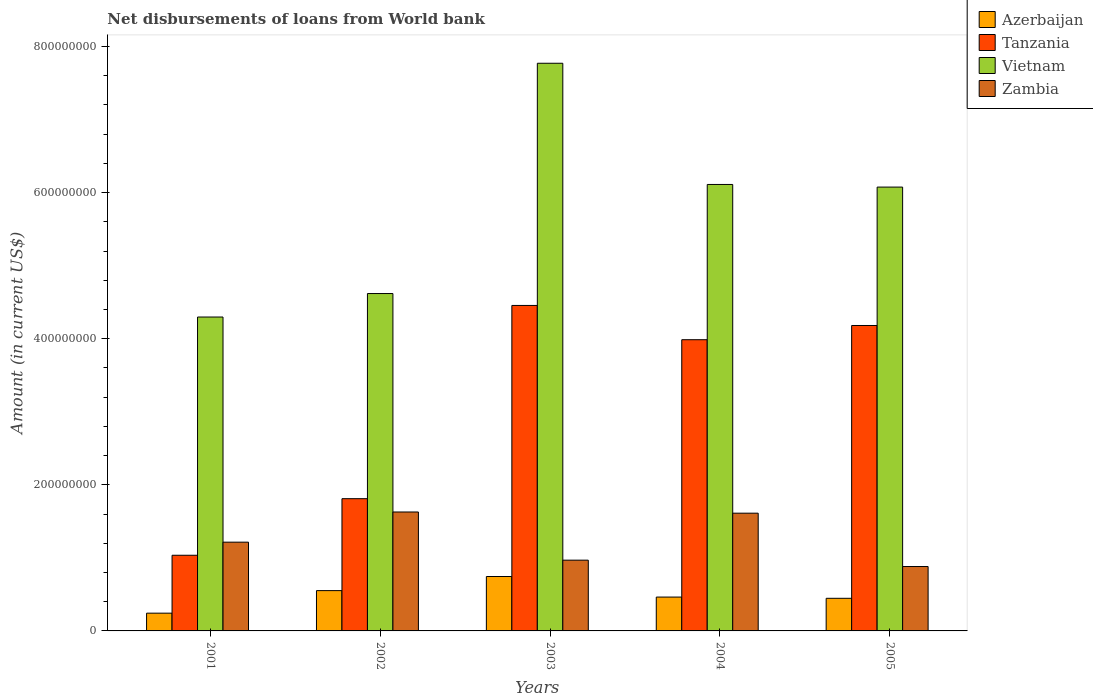Are the number of bars per tick equal to the number of legend labels?
Make the answer very short. Yes. Are the number of bars on each tick of the X-axis equal?
Your answer should be compact. Yes. What is the amount of loan disbursed from World Bank in Tanzania in 2003?
Your answer should be compact. 4.46e+08. Across all years, what is the maximum amount of loan disbursed from World Bank in Vietnam?
Give a very brief answer. 7.77e+08. Across all years, what is the minimum amount of loan disbursed from World Bank in Zambia?
Your answer should be very brief. 8.81e+07. What is the total amount of loan disbursed from World Bank in Azerbaijan in the graph?
Offer a very short reply. 2.45e+08. What is the difference between the amount of loan disbursed from World Bank in Tanzania in 2001 and that in 2003?
Offer a terse response. -3.42e+08. What is the difference between the amount of loan disbursed from World Bank in Tanzania in 2005 and the amount of loan disbursed from World Bank in Vietnam in 2001?
Provide a short and direct response. -1.16e+07. What is the average amount of loan disbursed from World Bank in Vietnam per year?
Your answer should be compact. 5.77e+08. In the year 2005, what is the difference between the amount of loan disbursed from World Bank in Vietnam and amount of loan disbursed from World Bank in Azerbaijan?
Provide a short and direct response. 5.63e+08. In how many years, is the amount of loan disbursed from World Bank in Zambia greater than 480000000 US$?
Give a very brief answer. 0. What is the ratio of the amount of loan disbursed from World Bank in Tanzania in 2002 to that in 2004?
Provide a succinct answer. 0.45. Is the amount of loan disbursed from World Bank in Azerbaijan in 2002 less than that in 2005?
Ensure brevity in your answer.  No. What is the difference between the highest and the second highest amount of loan disbursed from World Bank in Tanzania?
Provide a succinct answer. 2.74e+07. What is the difference between the highest and the lowest amount of loan disbursed from World Bank in Tanzania?
Provide a short and direct response. 3.42e+08. Is the sum of the amount of loan disbursed from World Bank in Azerbaijan in 2003 and 2005 greater than the maximum amount of loan disbursed from World Bank in Vietnam across all years?
Your response must be concise. No. Is it the case that in every year, the sum of the amount of loan disbursed from World Bank in Zambia and amount of loan disbursed from World Bank in Vietnam is greater than the sum of amount of loan disbursed from World Bank in Tanzania and amount of loan disbursed from World Bank in Azerbaijan?
Offer a terse response. Yes. What does the 2nd bar from the left in 2005 represents?
Keep it short and to the point. Tanzania. What does the 2nd bar from the right in 2005 represents?
Give a very brief answer. Vietnam. How many bars are there?
Offer a terse response. 20. How many years are there in the graph?
Ensure brevity in your answer.  5. Does the graph contain any zero values?
Provide a succinct answer. No. Where does the legend appear in the graph?
Provide a short and direct response. Top right. What is the title of the graph?
Provide a succinct answer. Net disbursements of loans from World bank. What is the label or title of the Y-axis?
Your answer should be compact. Amount (in current US$). What is the Amount (in current US$) of Azerbaijan in 2001?
Provide a succinct answer. 2.43e+07. What is the Amount (in current US$) in Tanzania in 2001?
Your answer should be compact. 1.04e+08. What is the Amount (in current US$) in Vietnam in 2001?
Offer a very short reply. 4.30e+08. What is the Amount (in current US$) of Zambia in 2001?
Offer a terse response. 1.21e+08. What is the Amount (in current US$) of Azerbaijan in 2002?
Ensure brevity in your answer.  5.52e+07. What is the Amount (in current US$) in Tanzania in 2002?
Your response must be concise. 1.81e+08. What is the Amount (in current US$) of Vietnam in 2002?
Ensure brevity in your answer.  4.62e+08. What is the Amount (in current US$) in Zambia in 2002?
Give a very brief answer. 1.63e+08. What is the Amount (in current US$) of Azerbaijan in 2003?
Make the answer very short. 7.45e+07. What is the Amount (in current US$) of Tanzania in 2003?
Ensure brevity in your answer.  4.46e+08. What is the Amount (in current US$) in Vietnam in 2003?
Your answer should be very brief. 7.77e+08. What is the Amount (in current US$) in Zambia in 2003?
Ensure brevity in your answer.  9.69e+07. What is the Amount (in current US$) in Azerbaijan in 2004?
Provide a succinct answer. 4.63e+07. What is the Amount (in current US$) of Tanzania in 2004?
Ensure brevity in your answer.  3.99e+08. What is the Amount (in current US$) of Vietnam in 2004?
Your answer should be very brief. 6.11e+08. What is the Amount (in current US$) of Zambia in 2004?
Offer a terse response. 1.61e+08. What is the Amount (in current US$) in Azerbaijan in 2005?
Provide a succinct answer. 4.46e+07. What is the Amount (in current US$) of Tanzania in 2005?
Your answer should be very brief. 4.18e+08. What is the Amount (in current US$) of Vietnam in 2005?
Your response must be concise. 6.08e+08. What is the Amount (in current US$) in Zambia in 2005?
Provide a succinct answer. 8.81e+07. Across all years, what is the maximum Amount (in current US$) in Azerbaijan?
Your answer should be very brief. 7.45e+07. Across all years, what is the maximum Amount (in current US$) of Tanzania?
Offer a terse response. 4.46e+08. Across all years, what is the maximum Amount (in current US$) of Vietnam?
Your response must be concise. 7.77e+08. Across all years, what is the maximum Amount (in current US$) in Zambia?
Your answer should be very brief. 1.63e+08. Across all years, what is the minimum Amount (in current US$) in Azerbaijan?
Offer a terse response. 2.43e+07. Across all years, what is the minimum Amount (in current US$) in Tanzania?
Provide a succinct answer. 1.04e+08. Across all years, what is the minimum Amount (in current US$) of Vietnam?
Keep it short and to the point. 4.30e+08. Across all years, what is the minimum Amount (in current US$) in Zambia?
Provide a short and direct response. 8.81e+07. What is the total Amount (in current US$) in Azerbaijan in the graph?
Give a very brief answer. 2.45e+08. What is the total Amount (in current US$) in Tanzania in the graph?
Your answer should be compact. 1.55e+09. What is the total Amount (in current US$) in Vietnam in the graph?
Provide a short and direct response. 2.89e+09. What is the total Amount (in current US$) in Zambia in the graph?
Give a very brief answer. 6.30e+08. What is the difference between the Amount (in current US$) of Azerbaijan in 2001 and that in 2002?
Provide a short and direct response. -3.09e+07. What is the difference between the Amount (in current US$) of Tanzania in 2001 and that in 2002?
Make the answer very short. -7.74e+07. What is the difference between the Amount (in current US$) of Vietnam in 2001 and that in 2002?
Offer a terse response. -3.22e+07. What is the difference between the Amount (in current US$) of Zambia in 2001 and that in 2002?
Provide a succinct answer. -4.13e+07. What is the difference between the Amount (in current US$) of Azerbaijan in 2001 and that in 2003?
Offer a very short reply. -5.02e+07. What is the difference between the Amount (in current US$) in Tanzania in 2001 and that in 2003?
Make the answer very short. -3.42e+08. What is the difference between the Amount (in current US$) in Vietnam in 2001 and that in 2003?
Provide a succinct answer. -3.47e+08. What is the difference between the Amount (in current US$) of Zambia in 2001 and that in 2003?
Provide a short and direct response. 2.46e+07. What is the difference between the Amount (in current US$) of Azerbaijan in 2001 and that in 2004?
Offer a very short reply. -2.20e+07. What is the difference between the Amount (in current US$) of Tanzania in 2001 and that in 2004?
Provide a short and direct response. -2.95e+08. What is the difference between the Amount (in current US$) in Vietnam in 2001 and that in 2004?
Provide a short and direct response. -1.81e+08. What is the difference between the Amount (in current US$) of Zambia in 2001 and that in 2004?
Make the answer very short. -3.97e+07. What is the difference between the Amount (in current US$) of Azerbaijan in 2001 and that in 2005?
Provide a succinct answer. -2.04e+07. What is the difference between the Amount (in current US$) in Tanzania in 2001 and that in 2005?
Offer a terse response. -3.15e+08. What is the difference between the Amount (in current US$) in Vietnam in 2001 and that in 2005?
Offer a terse response. -1.78e+08. What is the difference between the Amount (in current US$) in Zambia in 2001 and that in 2005?
Your answer should be compact. 3.33e+07. What is the difference between the Amount (in current US$) of Azerbaijan in 2002 and that in 2003?
Your response must be concise. -1.93e+07. What is the difference between the Amount (in current US$) of Tanzania in 2002 and that in 2003?
Provide a short and direct response. -2.65e+08. What is the difference between the Amount (in current US$) of Vietnam in 2002 and that in 2003?
Your answer should be compact. -3.15e+08. What is the difference between the Amount (in current US$) of Zambia in 2002 and that in 2003?
Give a very brief answer. 6.59e+07. What is the difference between the Amount (in current US$) in Azerbaijan in 2002 and that in 2004?
Your answer should be compact. 8.82e+06. What is the difference between the Amount (in current US$) in Tanzania in 2002 and that in 2004?
Your response must be concise. -2.18e+08. What is the difference between the Amount (in current US$) in Vietnam in 2002 and that in 2004?
Give a very brief answer. -1.49e+08. What is the difference between the Amount (in current US$) in Zambia in 2002 and that in 2004?
Your answer should be very brief. 1.63e+06. What is the difference between the Amount (in current US$) of Azerbaijan in 2002 and that in 2005?
Make the answer very short. 1.05e+07. What is the difference between the Amount (in current US$) of Tanzania in 2002 and that in 2005?
Your answer should be very brief. -2.37e+08. What is the difference between the Amount (in current US$) of Vietnam in 2002 and that in 2005?
Keep it short and to the point. -1.46e+08. What is the difference between the Amount (in current US$) of Zambia in 2002 and that in 2005?
Offer a terse response. 7.46e+07. What is the difference between the Amount (in current US$) of Azerbaijan in 2003 and that in 2004?
Give a very brief answer. 2.81e+07. What is the difference between the Amount (in current US$) in Tanzania in 2003 and that in 2004?
Offer a terse response. 4.69e+07. What is the difference between the Amount (in current US$) of Vietnam in 2003 and that in 2004?
Give a very brief answer. 1.66e+08. What is the difference between the Amount (in current US$) of Zambia in 2003 and that in 2004?
Give a very brief answer. -6.43e+07. What is the difference between the Amount (in current US$) in Azerbaijan in 2003 and that in 2005?
Your answer should be very brief. 2.98e+07. What is the difference between the Amount (in current US$) of Tanzania in 2003 and that in 2005?
Your answer should be compact. 2.74e+07. What is the difference between the Amount (in current US$) of Vietnam in 2003 and that in 2005?
Offer a very short reply. 1.69e+08. What is the difference between the Amount (in current US$) of Zambia in 2003 and that in 2005?
Provide a succinct answer. 8.70e+06. What is the difference between the Amount (in current US$) of Azerbaijan in 2004 and that in 2005?
Keep it short and to the point. 1.70e+06. What is the difference between the Amount (in current US$) in Tanzania in 2004 and that in 2005?
Provide a succinct answer. -1.95e+07. What is the difference between the Amount (in current US$) of Vietnam in 2004 and that in 2005?
Keep it short and to the point. 3.59e+06. What is the difference between the Amount (in current US$) in Zambia in 2004 and that in 2005?
Offer a very short reply. 7.30e+07. What is the difference between the Amount (in current US$) in Azerbaijan in 2001 and the Amount (in current US$) in Tanzania in 2002?
Make the answer very short. -1.57e+08. What is the difference between the Amount (in current US$) in Azerbaijan in 2001 and the Amount (in current US$) in Vietnam in 2002?
Provide a succinct answer. -4.38e+08. What is the difference between the Amount (in current US$) of Azerbaijan in 2001 and the Amount (in current US$) of Zambia in 2002?
Provide a short and direct response. -1.39e+08. What is the difference between the Amount (in current US$) of Tanzania in 2001 and the Amount (in current US$) of Vietnam in 2002?
Give a very brief answer. -3.58e+08. What is the difference between the Amount (in current US$) in Tanzania in 2001 and the Amount (in current US$) in Zambia in 2002?
Ensure brevity in your answer.  -5.92e+07. What is the difference between the Amount (in current US$) of Vietnam in 2001 and the Amount (in current US$) of Zambia in 2002?
Keep it short and to the point. 2.67e+08. What is the difference between the Amount (in current US$) in Azerbaijan in 2001 and the Amount (in current US$) in Tanzania in 2003?
Give a very brief answer. -4.21e+08. What is the difference between the Amount (in current US$) of Azerbaijan in 2001 and the Amount (in current US$) of Vietnam in 2003?
Your answer should be compact. -7.53e+08. What is the difference between the Amount (in current US$) of Azerbaijan in 2001 and the Amount (in current US$) of Zambia in 2003?
Make the answer very short. -7.26e+07. What is the difference between the Amount (in current US$) of Tanzania in 2001 and the Amount (in current US$) of Vietnam in 2003?
Give a very brief answer. -6.73e+08. What is the difference between the Amount (in current US$) in Tanzania in 2001 and the Amount (in current US$) in Zambia in 2003?
Provide a succinct answer. 6.72e+06. What is the difference between the Amount (in current US$) of Vietnam in 2001 and the Amount (in current US$) of Zambia in 2003?
Give a very brief answer. 3.33e+08. What is the difference between the Amount (in current US$) of Azerbaijan in 2001 and the Amount (in current US$) of Tanzania in 2004?
Provide a short and direct response. -3.74e+08. What is the difference between the Amount (in current US$) of Azerbaijan in 2001 and the Amount (in current US$) of Vietnam in 2004?
Your answer should be very brief. -5.87e+08. What is the difference between the Amount (in current US$) in Azerbaijan in 2001 and the Amount (in current US$) in Zambia in 2004?
Offer a terse response. -1.37e+08. What is the difference between the Amount (in current US$) in Tanzania in 2001 and the Amount (in current US$) in Vietnam in 2004?
Your answer should be compact. -5.08e+08. What is the difference between the Amount (in current US$) of Tanzania in 2001 and the Amount (in current US$) of Zambia in 2004?
Make the answer very short. -5.76e+07. What is the difference between the Amount (in current US$) in Vietnam in 2001 and the Amount (in current US$) in Zambia in 2004?
Provide a succinct answer. 2.69e+08. What is the difference between the Amount (in current US$) of Azerbaijan in 2001 and the Amount (in current US$) of Tanzania in 2005?
Your answer should be very brief. -3.94e+08. What is the difference between the Amount (in current US$) in Azerbaijan in 2001 and the Amount (in current US$) in Vietnam in 2005?
Provide a short and direct response. -5.83e+08. What is the difference between the Amount (in current US$) of Azerbaijan in 2001 and the Amount (in current US$) of Zambia in 2005?
Offer a very short reply. -6.39e+07. What is the difference between the Amount (in current US$) in Tanzania in 2001 and the Amount (in current US$) in Vietnam in 2005?
Offer a very short reply. -5.04e+08. What is the difference between the Amount (in current US$) of Tanzania in 2001 and the Amount (in current US$) of Zambia in 2005?
Give a very brief answer. 1.54e+07. What is the difference between the Amount (in current US$) in Vietnam in 2001 and the Amount (in current US$) in Zambia in 2005?
Ensure brevity in your answer.  3.42e+08. What is the difference between the Amount (in current US$) of Azerbaijan in 2002 and the Amount (in current US$) of Tanzania in 2003?
Your answer should be very brief. -3.90e+08. What is the difference between the Amount (in current US$) of Azerbaijan in 2002 and the Amount (in current US$) of Vietnam in 2003?
Keep it short and to the point. -7.22e+08. What is the difference between the Amount (in current US$) in Azerbaijan in 2002 and the Amount (in current US$) in Zambia in 2003?
Give a very brief answer. -4.17e+07. What is the difference between the Amount (in current US$) of Tanzania in 2002 and the Amount (in current US$) of Vietnam in 2003?
Your answer should be compact. -5.96e+08. What is the difference between the Amount (in current US$) in Tanzania in 2002 and the Amount (in current US$) in Zambia in 2003?
Provide a succinct answer. 8.42e+07. What is the difference between the Amount (in current US$) in Vietnam in 2002 and the Amount (in current US$) in Zambia in 2003?
Provide a short and direct response. 3.65e+08. What is the difference between the Amount (in current US$) in Azerbaijan in 2002 and the Amount (in current US$) in Tanzania in 2004?
Make the answer very short. -3.43e+08. What is the difference between the Amount (in current US$) of Azerbaijan in 2002 and the Amount (in current US$) of Vietnam in 2004?
Give a very brief answer. -5.56e+08. What is the difference between the Amount (in current US$) in Azerbaijan in 2002 and the Amount (in current US$) in Zambia in 2004?
Your answer should be very brief. -1.06e+08. What is the difference between the Amount (in current US$) in Tanzania in 2002 and the Amount (in current US$) in Vietnam in 2004?
Your response must be concise. -4.30e+08. What is the difference between the Amount (in current US$) of Tanzania in 2002 and the Amount (in current US$) of Zambia in 2004?
Provide a short and direct response. 1.98e+07. What is the difference between the Amount (in current US$) in Vietnam in 2002 and the Amount (in current US$) in Zambia in 2004?
Give a very brief answer. 3.01e+08. What is the difference between the Amount (in current US$) in Azerbaijan in 2002 and the Amount (in current US$) in Tanzania in 2005?
Make the answer very short. -3.63e+08. What is the difference between the Amount (in current US$) in Azerbaijan in 2002 and the Amount (in current US$) in Vietnam in 2005?
Your response must be concise. -5.52e+08. What is the difference between the Amount (in current US$) in Azerbaijan in 2002 and the Amount (in current US$) in Zambia in 2005?
Your answer should be compact. -3.30e+07. What is the difference between the Amount (in current US$) of Tanzania in 2002 and the Amount (in current US$) of Vietnam in 2005?
Your answer should be very brief. -4.27e+08. What is the difference between the Amount (in current US$) of Tanzania in 2002 and the Amount (in current US$) of Zambia in 2005?
Ensure brevity in your answer.  9.29e+07. What is the difference between the Amount (in current US$) in Vietnam in 2002 and the Amount (in current US$) in Zambia in 2005?
Ensure brevity in your answer.  3.74e+08. What is the difference between the Amount (in current US$) in Azerbaijan in 2003 and the Amount (in current US$) in Tanzania in 2004?
Give a very brief answer. -3.24e+08. What is the difference between the Amount (in current US$) in Azerbaijan in 2003 and the Amount (in current US$) in Vietnam in 2004?
Keep it short and to the point. -5.37e+08. What is the difference between the Amount (in current US$) of Azerbaijan in 2003 and the Amount (in current US$) of Zambia in 2004?
Provide a succinct answer. -8.67e+07. What is the difference between the Amount (in current US$) in Tanzania in 2003 and the Amount (in current US$) in Vietnam in 2004?
Your response must be concise. -1.66e+08. What is the difference between the Amount (in current US$) in Tanzania in 2003 and the Amount (in current US$) in Zambia in 2004?
Your response must be concise. 2.84e+08. What is the difference between the Amount (in current US$) in Vietnam in 2003 and the Amount (in current US$) in Zambia in 2004?
Give a very brief answer. 6.16e+08. What is the difference between the Amount (in current US$) of Azerbaijan in 2003 and the Amount (in current US$) of Tanzania in 2005?
Provide a short and direct response. -3.44e+08. What is the difference between the Amount (in current US$) of Azerbaijan in 2003 and the Amount (in current US$) of Vietnam in 2005?
Keep it short and to the point. -5.33e+08. What is the difference between the Amount (in current US$) in Azerbaijan in 2003 and the Amount (in current US$) in Zambia in 2005?
Keep it short and to the point. -1.37e+07. What is the difference between the Amount (in current US$) of Tanzania in 2003 and the Amount (in current US$) of Vietnam in 2005?
Make the answer very short. -1.62e+08. What is the difference between the Amount (in current US$) of Tanzania in 2003 and the Amount (in current US$) of Zambia in 2005?
Give a very brief answer. 3.57e+08. What is the difference between the Amount (in current US$) in Vietnam in 2003 and the Amount (in current US$) in Zambia in 2005?
Your answer should be very brief. 6.89e+08. What is the difference between the Amount (in current US$) of Azerbaijan in 2004 and the Amount (in current US$) of Tanzania in 2005?
Provide a short and direct response. -3.72e+08. What is the difference between the Amount (in current US$) in Azerbaijan in 2004 and the Amount (in current US$) in Vietnam in 2005?
Keep it short and to the point. -5.61e+08. What is the difference between the Amount (in current US$) of Azerbaijan in 2004 and the Amount (in current US$) of Zambia in 2005?
Your response must be concise. -4.18e+07. What is the difference between the Amount (in current US$) of Tanzania in 2004 and the Amount (in current US$) of Vietnam in 2005?
Your answer should be compact. -2.09e+08. What is the difference between the Amount (in current US$) of Tanzania in 2004 and the Amount (in current US$) of Zambia in 2005?
Ensure brevity in your answer.  3.10e+08. What is the difference between the Amount (in current US$) of Vietnam in 2004 and the Amount (in current US$) of Zambia in 2005?
Provide a succinct answer. 5.23e+08. What is the average Amount (in current US$) of Azerbaijan per year?
Keep it short and to the point. 4.90e+07. What is the average Amount (in current US$) of Tanzania per year?
Your answer should be very brief. 3.09e+08. What is the average Amount (in current US$) of Vietnam per year?
Your answer should be compact. 5.77e+08. What is the average Amount (in current US$) of Zambia per year?
Give a very brief answer. 1.26e+08. In the year 2001, what is the difference between the Amount (in current US$) in Azerbaijan and Amount (in current US$) in Tanzania?
Provide a succinct answer. -7.93e+07. In the year 2001, what is the difference between the Amount (in current US$) of Azerbaijan and Amount (in current US$) of Vietnam?
Offer a terse response. -4.05e+08. In the year 2001, what is the difference between the Amount (in current US$) in Azerbaijan and Amount (in current US$) in Zambia?
Make the answer very short. -9.72e+07. In the year 2001, what is the difference between the Amount (in current US$) in Tanzania and Amount (in current US$) in Vietnam?
Provide a succinct answer. -3.26e+08. In the year 2001, what is the difference between the Amount (in current US$) in Tanzania and Amount (in current US$) in Zambia?
Give a very brief answer. -1.79e+07. In the year 2001, what is the difference between the Amount (in current US$) in Vietnam and Amount (in current US$) in Zambia?
Provide a short and direct response. 3.08e+08. In the year 2002, what is the difference between the Amount (in current US$) in Azerbaijan and Amount (in current US$) in Tanzania?
Your answer should be very brief. -1.26e+08. In the year 2002, what is the difference between the Amount (in current US$) of Azerbaijan and Amount (in current US$) of Vietnam?
Keep it short and to the point. -4.07e+08. In the year 2002, what is the difference between the Amount (in current US$) of Azerbaijan and Amount (in current US$) of Zambia?
Offer a terse response. -1.08e+08. In the year 2002, what is the difference between the Amount (in current US$) of Tanzania and Amount (in current US$) of Vietnam?
Provide a short and direct response. -2.81e+08. In the year 2002, what is the difference between the Amount (in current US$) in Tanzania and Amount (in current US$) in Zambia?
Give a very brief answer. 1.82e+07. In the year 2002, what is the difference between the Amount (in current US$) in Vietnam and Amount (in current US$) in Zambia?
Your response must be concise. 2.99e+08. In the year 2003, what is the difference between the Amount (in current US$) in Azerbaijan and Amount (in current US$) in Tanzania?
Offer a terse response. -3.71e+08. In the year 2003, what is the difference between the Amount (in current US$) of Azerbaijan and Amount (in current US$) of Vietnam?
Offer a terse response. -7.03e+08. In the year 2003, what is the difference between the Amount (in current US$) in Azerbaijan and Amount (in current US$) in Zambia?
Your answer should be compact. -2.24e+07. In the year 2003, what is the difference between the Amount (in current US$) of Tanzania and Amount (in current US$) of Vietnam?
Ensure brevity in your answer.  -3.32e+08. In the year 2003, what is the difference between the Amount (in current US$) of Tanzania and Amount (in current US$) of Zambia?
Make the answer very short. 3.49e+08. In the year 2003, what is the difference between the Amount (in current US$) of Vietnam and Amount (in current US$) of Zambia?
Make the answer very short. 6.80e+08. In the year 2004, what is the difference between the Amount (in current US$) in Azerbaijan and Amount (in current US$) in Tanzania?
Keep it short and to the point. -3.52e+08. In the year 2004, what is the difference between the Amount (in current US$) in Azerbaijan and Amount (in current US$) in Vietnam?
Make the answer very short. -5.65e+08. In the year 2004, what is the difference between the Amount (in current US$) of Azerbaijan and Amount (in current US$) of Zambia?
Provide a succinct answer. -1.15e+08. In the year 2004, what is the difference between the Amount (in current US$) in Tanzania and Amount (in current US$) in Vietnam?
Keep it short and to the point. -2.13e+08. In the year 2004, what is the difference between the Amount (in current US$) of Tanzania and Amount (in current US$) of Zambia?
Your answer should be compact. 2.37e+08. In the year 2004, what is the difference between the Amount (in current US$) in Vietnam and Amount (in current US$) in Zambia?
Ensure brevity in your answer.  4.50e+08. In the year 2005, what is the difference between the Amount (in current US$) of Azerbaijan and Amount (in current US$) of Tanzania?
Offer a very short reply. -3.73e+08. In the year 2005, what is the difference between the Amount (in current US$) of Azerbaijan and Amount (in current US$) of Vietnam?
Make the answer very short. -5.63e+08. In the year 2005, what is the difference between the Amount (in current US$) in Azerbaijan and Amount (in current US$) in Zambia?
Provide a succinct answer. -4.35e+07. In the year 2005, what is the difference between the Amount (in current US$) in Tanzania and Amount (in current US$) in Vietnam?
Provide a short and direct response. -1.89e+08. In the year 2005, what is the difference between the Amount (in current US$) in Tanzania and Amount (in current US$) in Zambia?
Your answer should be compact. 3.30e+08. In the year 2005, what is the difference between the Amount (in current US$) of Vietnam and Amount (in current US$) of Zambia?
Your answer should be compact. 5.19e+08. What is the ratio of the Amount (in current US$) in Azerbaijan in 2001 to that in 2002?
Offer a very short reply. 0.44. What is the ratio of the Amount (in current US$) in Tanzania in 2001 to that in 2002?
Your answer should be compact. 0.57. What is the ratio of the Amount (in current US$) in Vietnam in 2001 to that in 2002?
Make the answer very short. 0.93. What is the ratio of the Amount (in current US$) in Zambia in 2001 to that in 2002?
Give a very brief answer. 0.75. What is the ratio of the Amount (in current US$) in Azerbaijan in 2001 to that in 2003?
Your answer should be very brief. 0.33. What is the ratio of the Amount (in current US$) in Tanzania in 2001 to that in 2003?
Your response must be concise. 0.23. What is the ratio of the Amount (in current US$) in Vietnam in 2001 to that in 2003?
Give a very brief answer. 0.55. What is the ratio of the Amount (in current US$) of Zambia in 2001 to that in 2003?
Make the answer very short. 1.25. What is the ratio of the Amount (in current US$) of Azerbaijan in 2001 to that in 2004?
Make the answer very short. 0.52. What is the ratio of the Amount (in current US$) of Tanzania in 2001 to that in 2004?
Offer a very short reply. 0.26. What is the ratio of the Amount (in current US$) in Vietnam in 2001 to that in 2004?
Offer a very short reply. 0.7. What is the ratio of the Amount (in current US$) in Zambia in 2001 to that in 2004?
Ensure brevity in your answer.  0.75. What is the ratio of the Amount (in current US$) of Azerbaijan in 2001 to that in 2005?
Give a very brief answer. 0.54. What is the ratio of the Amount (in current US$) of Tanzania in 2001 to that in 2005?
Offer a very short reply. 0.25. What is the ratio of the Amount (in current US$) of Vietnam in 2001 to that in 2005?
Provide a short and direct response. 0.71. What is the ratio of the Amount (in current US$) in Zambia in 2001 to that in 2005?
Offer a very short reply. 1.38. What is the ratio of the Amount (in current US$) in Azerbaijan in 2002 to that in 2003?
Keep it short and to the point. 0.74. What is the ratio of the Amount (in current US$) in Tanzania in 2002 to that in 2003?
Your answer should be compact. 0.41. What is the ratio of the Amount (in current US$) of Vietnam in 2002 to that in 2003?
Provide a succinct answer. 0.59. What is the ratio of the Amount (in current US$) of Zambia in 2002 to that in 2003?
Provide a short and direct response. 1.68. What is the ratio of the Amount (in current US$) of Azerbaijan in 2002 to that in 2004?
Your answer should be compact. 1.19. What is the ratio of the Amount (in current US$) of Tanzania in 2002 to that in 2004?
Your response must be concise. 0.45. What is the ratio of the Amount (in current US$) of Vietnam in 2002 to that in 2004?
Provide a succinct answer. 0.76. What is the ratio of the Amount (in current US$) of Azerbaijan in 2002 to that in 2005?
Ensure brevity in your answer.  1.24. What is the ratio of the Amount (in current US$) in Tanzania in 2002 to that in 2005?
Provide a succinct answer. 0.43. What is the ratio of the Amount (in current US$) in Vietnam in 2002 to that in 2005?
Offer a very short reply. 0.76. What is the ratio of the Amount (in current US$) of Zambia in 2002 to that in 2005?
Ensure brevity in your answer.  1.85. What is the ratio of the Amount (in current US$) in Azerbaijan in 2003 to that in 2004?
Offer a terse response. 1.61. What is the ratio of the Amount (in current US$) of Tanzania in 2003 to that in 2004?
Provide a short and direct response. 1.12. What is the ratio of the Amount (in current US$) of Vietnam in 2003 to that in 2004?
Offer a terse response. 1.27. What is the ratio of the Amount (in current US$) in Zambia in 2003 to that in 2004?
Offer a very short reply. 0.6. What is the ratio of the Amount (in current US$) in Azerbaijan in 2003 to that in 2005?
Offer a very short reply. 1.67. What is the ratio of the Amount (in current US$) in Tanzania in 2003 to that in 2005?
Offer a very short reply. 1.07. What is the ratio of the Amount (in current US$) in Vietnam in 2003 to that in 2005?
Your answer should be very brief. 1.28. What is the ratio of the Amount (in current US$) of Zambia in 2003 to that in 2005?
Make the answer very short. 1.1. What is the ratio of the Amount (in current US$) of Azerbaijan in 2004 to that in 2005?
Offer a terse response. 1.04. What is the ratio of the Amount (in current US$) in Tanzania in 2004 to that in 2005?
Provide a short and direct response. 0.95. What is the ratio of the Amount (in current US$) in Vietnam in 2004 to that in 2005?
Provide a short and direct response. 1.01. What is the ratio of the Amount (in current US$) of Zambia in 2004 to that in 2005?
Provide a succinct answer. 1.83. What is the difference between the highest and the second highest Amount (in current US$) of Azerbaijan?
Your response must be concise. 1.93e+07. What is the difference between the highest and the second highest Amount (in current US$) in Tanzania?
Make the answer very short. 2.74e+07. What is the difference between the highest and the second highest Amount (in current US$) of Vietnam?
Provide a succinct answer. 1.66e+08. What is the difference between the highest and the second highest Amount (in current US$) of Zambia?
Provide a succinct answer. 1.63e+06. What is the difference between the highest and the lowest Amount (in current US$) of Azerbaijan?
Provide a short and direct response. 5.02e+07. What is the difference between the highest and the lowest Amount (in current US$) of Tanzania?
Offer a very short reply. 3.42e+08. What is the difference between the highest and the lowest Amount (in current US$) of Vietnam?
Your answer should be very brief. 3.47e+08. What is the difference between the highest and the lowest Amount (in current US$) of Zambia?
Keep it short and to the point. 7.46e+07. 